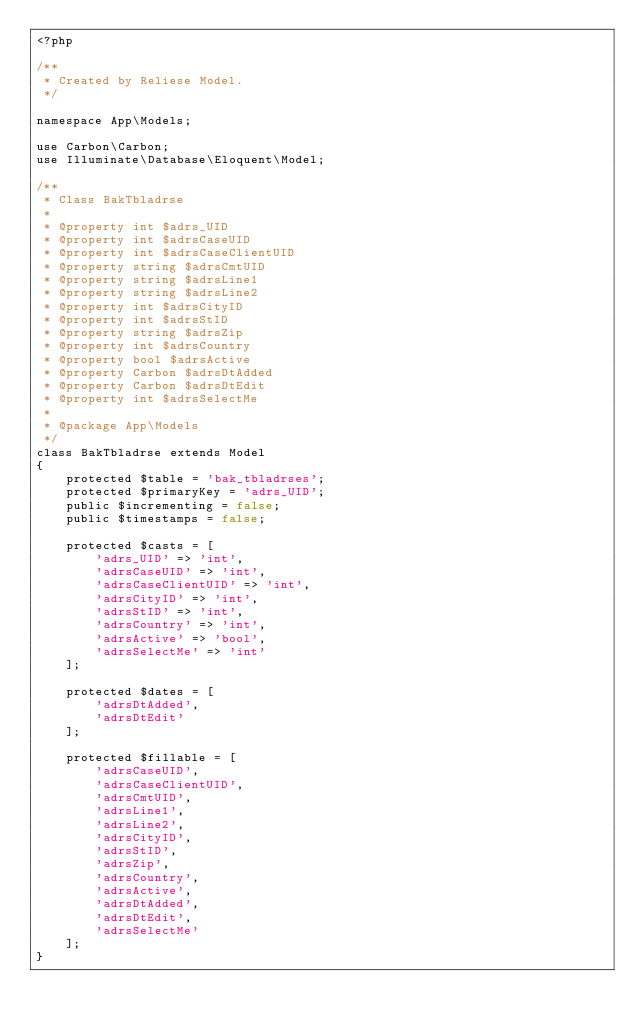<code> <loc_0><loc_0><loc_500><loc_500><_PHP_><?php

/**
 * Created by Reliese Model.
 */

namespace App\Models;

use Carbon\Carbon;
use Illuminate\Database\Eloquent\Model;

/**
 * Class BakTbladrse
 * 
 * @property int $adrs_UID
 * @property int $adrsCaseUID
 * @property int $adrsCaseClientUID
 * @property string $adrsCmtUID
 * @property string $adrsLine1
 * @property string $adrsLine2
 * @property int $adrsCityID
 * @property int $adrsStID
 * @property string $adrsZip
 * @property int $adrsCountry
 * @property bool $adrsActive
 * @property Carbon $adrsDtAdded
 * @property Carbon $adrsDtEdit
 * @property int $adrsSelectMe
 *
 * @package App\Models
 */
class BakTbladrse extends Model
{
	protected $table = 'bak_tbladrses';
	protected $primaryKey = 'adrs_UID';
	public $incrementing = false;
	public $timestamps = false;

	protected $casts = [
		'adrs_UID' => 'int',
		'adrsCaseUID' => 'int',
		'adrsCaseClientUID' => 'int',
		'adrsCityID' => 'int',
		'adrsStID' => 'int',
		'adrsCountry' => 'int',
		'adrsActive' => 'bool',
		'adrsSelectMe' => 'int'
	];

	protected $dates = [
		'adrsDtAdded',
		'adrsDtEdit'
	];

	protected $fillable = [
		'adrsCaseUID',
		'adrsCaseClientUID',
		'adrsCmtUID',
		'adrsLine1',
		'adrsLine2',
		'adrsCityID',
		'adrsStID',
		'adrsZip',
		'adrsCountry',
		'adrsActive',
		'adrsDtAdded',
		'adrsDtEdit',
		'adrsSelectMe'
	];
}
</code> 